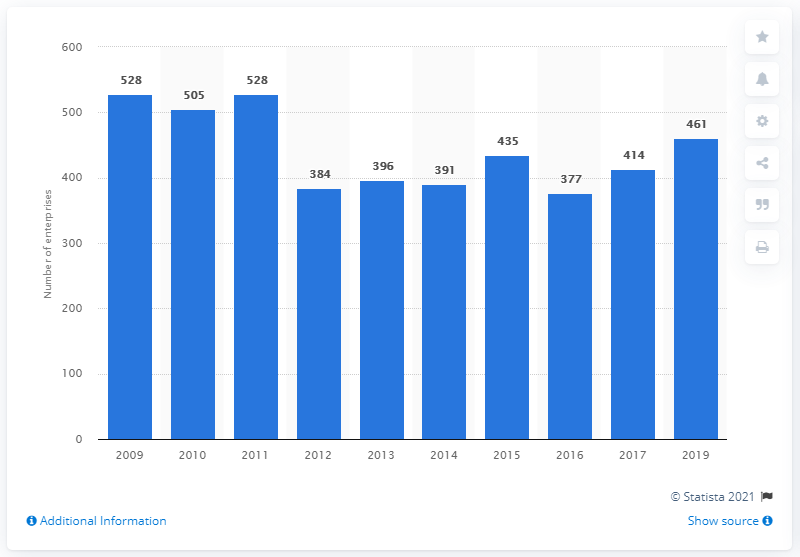Specify some key components in this picture. In 2018, there were 461 enterprises in the manufacturing of cocoa, chocolate and sugar confectionery industry in Belgium. 